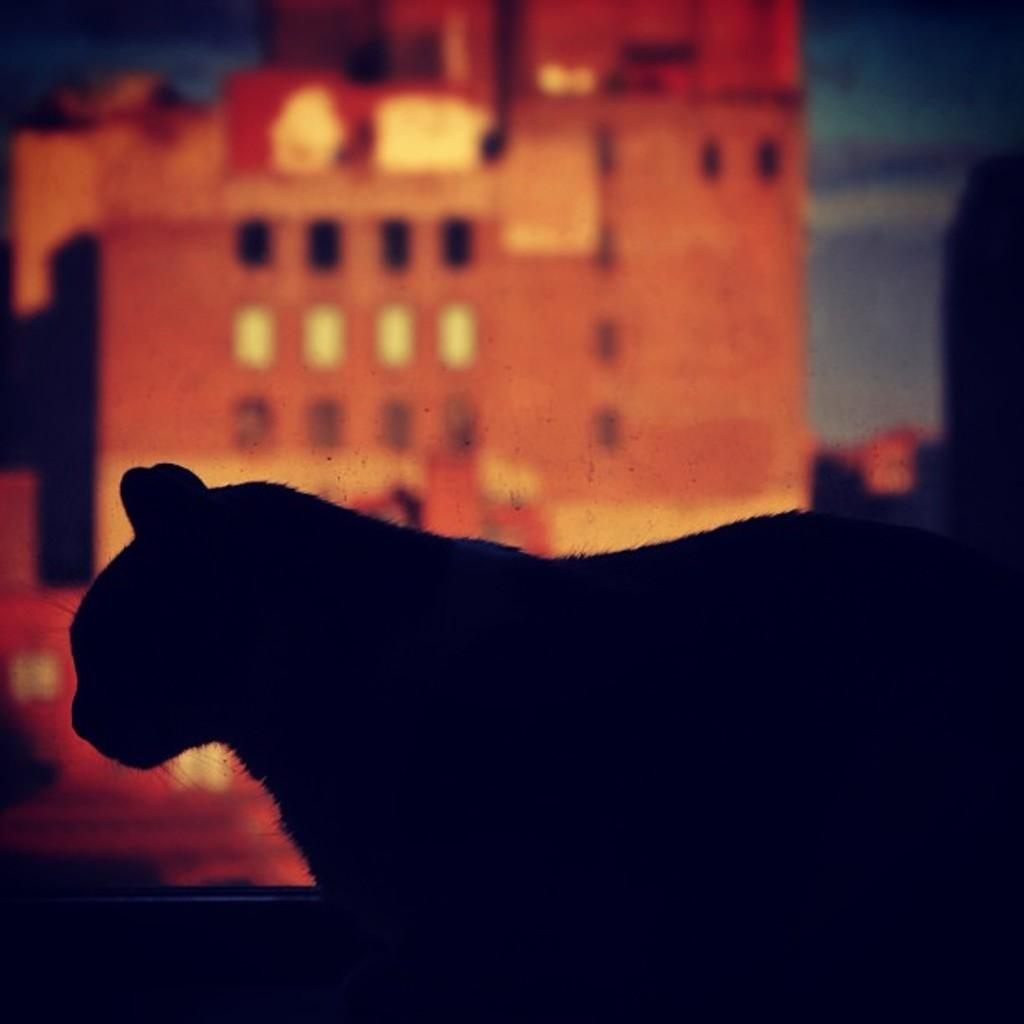What type of animal is present in the image? There is an animal in the image, but its specific type cannot be determined from the provided facts. What can be seen in the background of the image? There is a building in the background of the image. What is visible at the top of the image? The sky is visible at the top of the image. Can you tell me how many hooks are hanging from the animal's neck in the image? There are no hooks present in the image; it features an animal and a building in the background. What type of watch is the animal wearing in the image? There is no watch visible in the image; it only features an animal and a building in the background. 